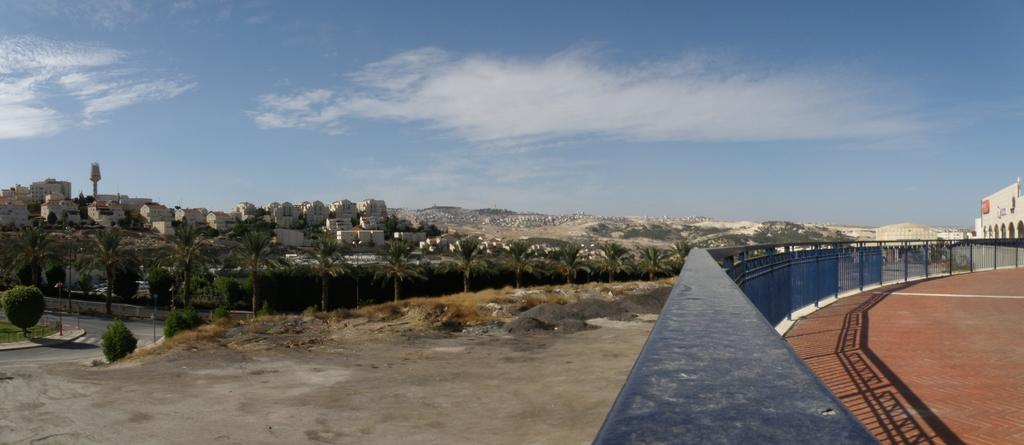What type of natural elements can be seen in the image? There are trees in the image. What type of man-made structures are present in the image? There are buildings in the image. What type of barrier can be seen in the image? There is a fence in the image. What is visible at the top of the image? The sky is visible at the top of the image. How many passengers are visible in the image? There are no passengers present in the image. What type of wood is used to construct the fence in the image? There is no information about the type of wood used to construct the fence in the image. 